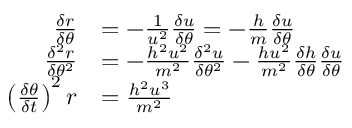Convert formula to latex. <formula><loc_0><loc_0><loc_500><loc_500>{ \begin{array} { r l } { { \frac { \delta r } { \delta \theta } } } & { = - { \frac { 1 } { u ^ { 2 } } } { \frac { \delta u } { \delta \theta } } = - { \frac { h } { m } } { \frac { \delta u } { \delta \theta } } } \\ { { \frac { \delta ^ { 2 } r } { \delta \theta ^ { 2 } } } } & { = - { \frac { h ^ { 2 } u ^ { 2 } } { m ^ { 2 } } } { \frac { \delta ^ { 2 } u } { \delta \theta ^ { 2 } } } - { \frac { h u ^ { 2 } } { m ^ { 2 } } } { \frac { \delta h } { \delta \theta } } { \frac { \delta u } { \delta \theta } } } \\ { \left ( { \frac { \delta \theta } { \delta t } } \right ) ^ { 2 } r } & { = { \frac { h ^ { 2 } u ^ { 3 } } { m ^ { 2 } } } } \end{array} }</formula> 